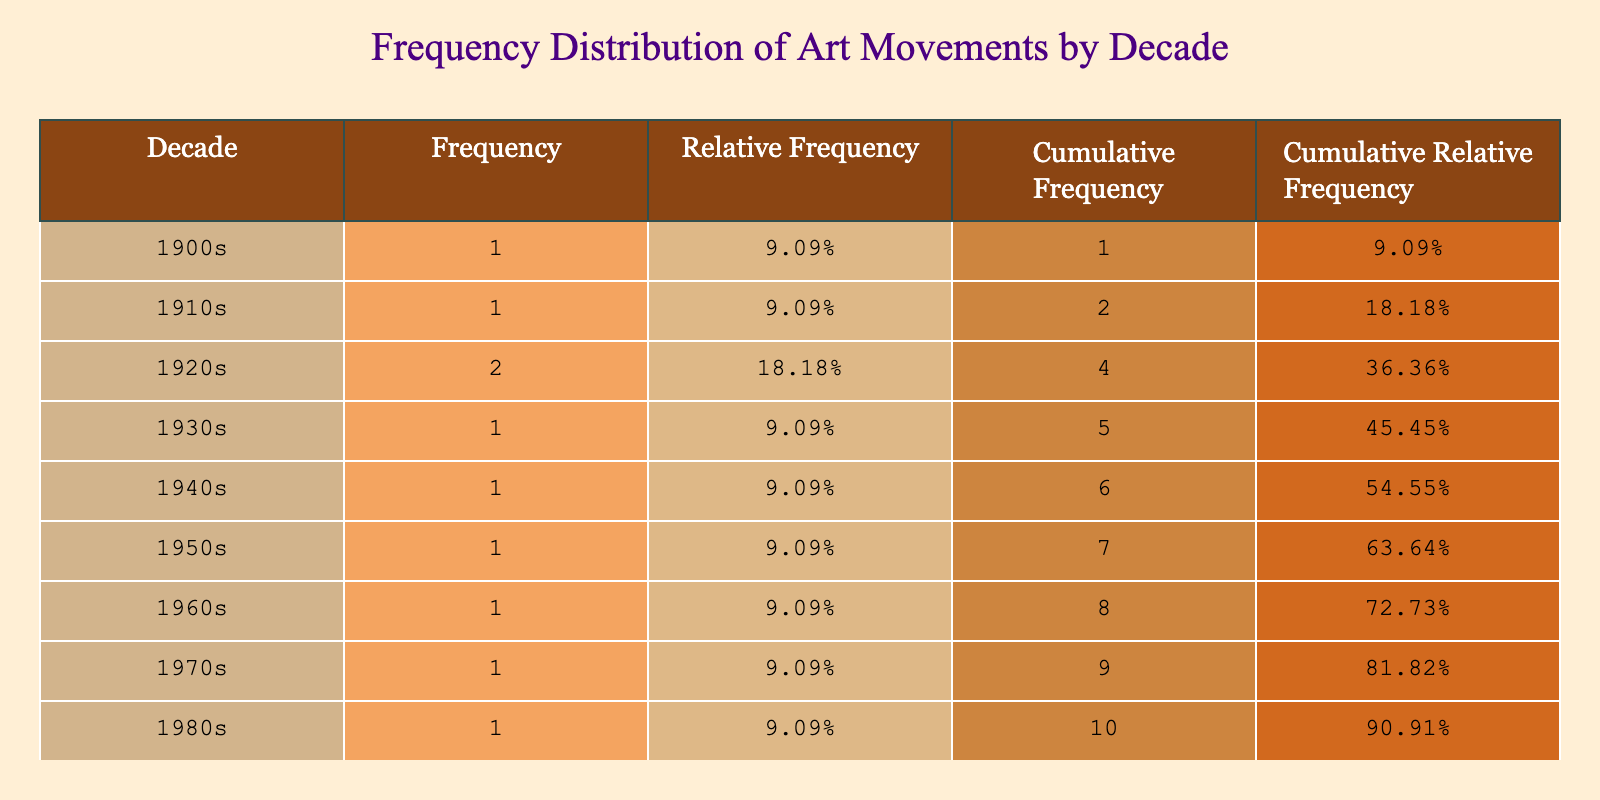What is the most represented art movement in the table? By looking at the table, we can identify the frequency of each art movement based on the decade. The art movement with the most occurrences would be the one with the highest frequency count. In this case, the table shows that every decade has one unique movement, indicating no repetitions, therefore, all movements are equally represented.
Answer: None Which decade had the "Dada" movement? According to the table, the "Dada" movement is listed under the 1920s. We can find this by scanning through the "Art Movement" column to see where "Dada" appears.
Answer: 1920s How many different art movements were documented in the table? By looking at the “Art Movement” column, we can count the distinct movements listed. The table shows a total of 10 unique movements from the 1900s to 1990s.
Answer: 10 Was "Surrealism" present in the 1930s? The table can be consulted to see if "Surrealism" is listed in the 1930s row. Since it is noted in the 1920s column, we can conclude that "Surrealism" was not in the 1930s.
Answer: No What is the cumulative frequency of art movements up to the 1960s? We need to calculate the cumulative frequency for the decades until the 1960s by adding up their frequencies. The cumulative frequencies are: 1900s (1) + 1910s (1) + 1920s (2) + 1930s (1) + 1940s (1) + 1950s (1) = 7 total cumulative frequencies up to the end of the 1960s.
Answer: 7 Which decade shows the movement "Action Painting"? The table shows "Action Painting" under the 1940s category. To find it, we look at the "Art Movement" column and identify where "Action Painting" is listed.
Answer: 1940s What is the total frequency of art movements documented in the 1970s and 1980s combined? To find this, we check the number of movements listed for both decades. The 1970s have one movement (Conceptual Art) and the 1980s also have one movement (Neo-Expressionism). Adding these gives a total of 2 movements.
Answer: 2 Is "Installation Art" the last movement documented in the table? Looking at the table, "Installation Art" is categorized under the 1990s, which is the last row. Therefore, it confirms that "Installation Art" is indeed the last movement listed.
Answer: Yes How does the relative frequency of the Pop Art movement compare to Dada? We must find the relative frequency of both the Pop Art and Dada movements listed for their respective decades. Each art movement has a relative frequency of 0.1 (1 out of 10), resulting in them being equal.
Answer: They are equal 